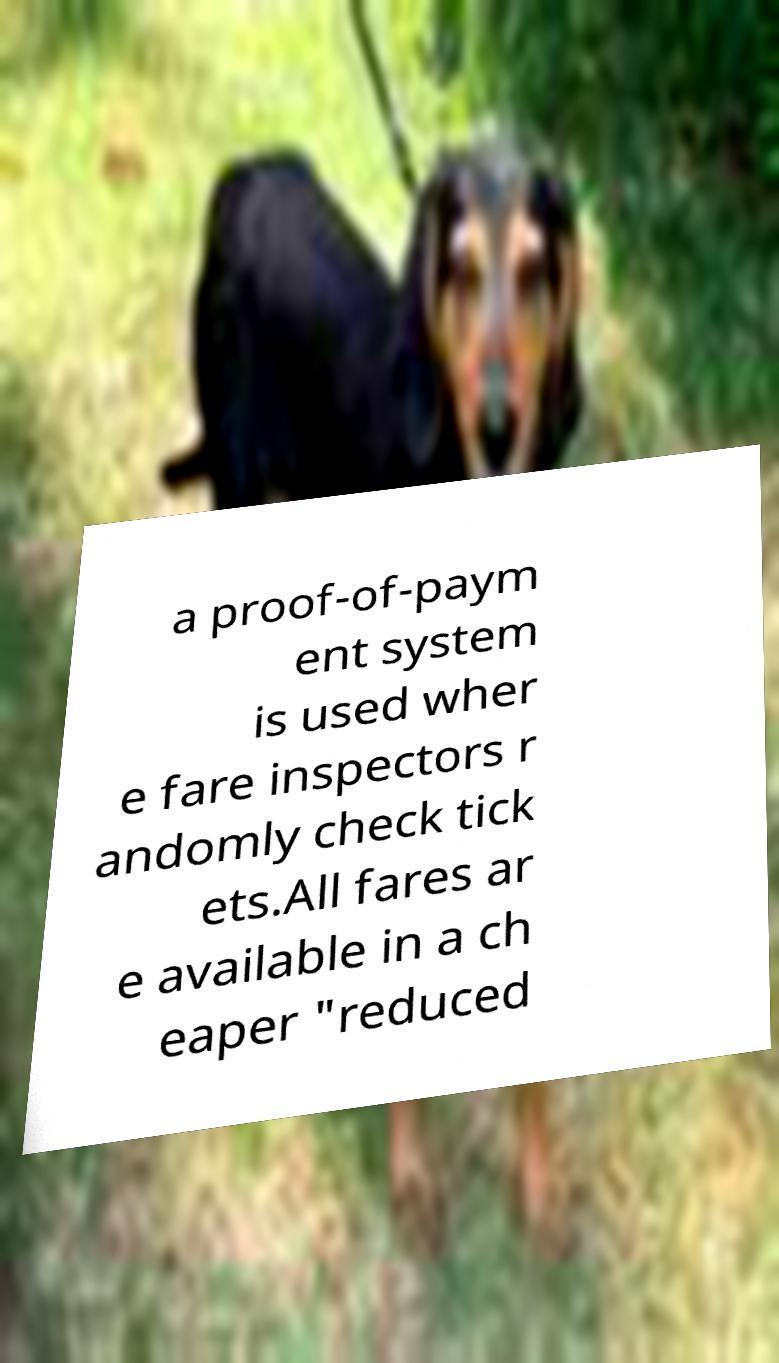Please read and relay the text visible in this image. What does it say? a proof-of-paym ent system is used wher e fare inspectors r andomly check tick ets.All fares ar e available in a ch eaper "reduced 